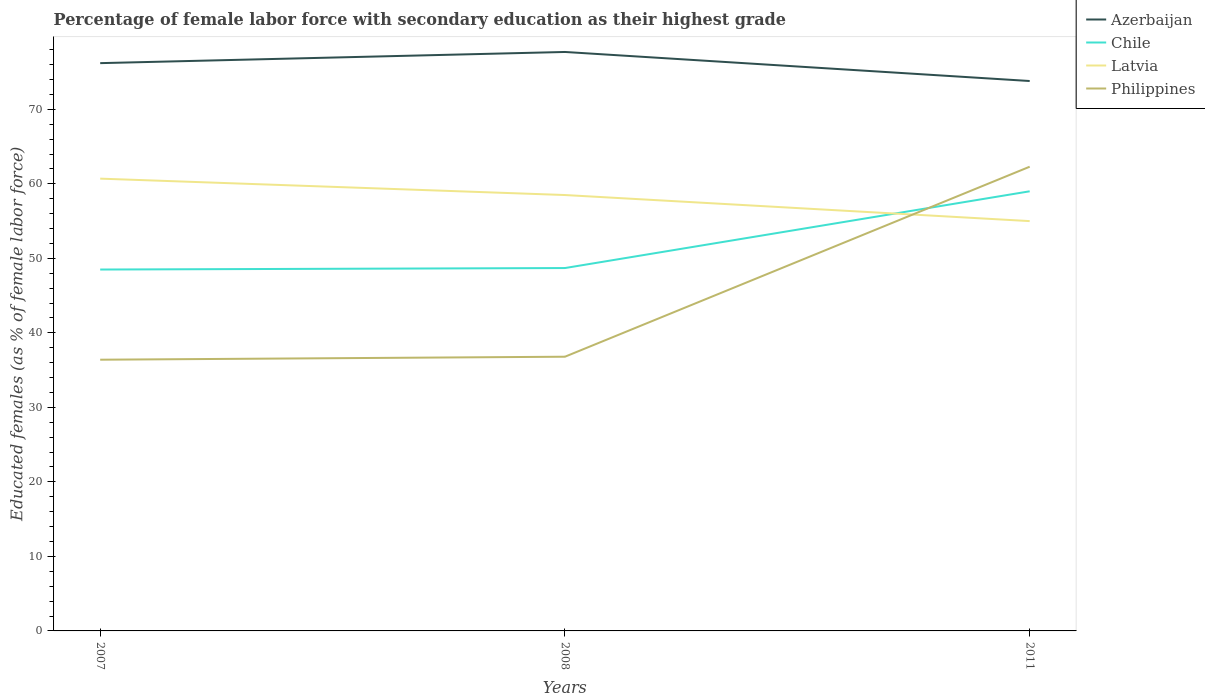How many different coloured lines are there?
Offer a very short reply. 4. Does the line corresponding to Latvia intersect with the line corresponding to Azerbaijan?
Make the answer very short. No. Is the number of lines equal to the number of legend labels?
Keep it short and to the point. Yes. Across all years, what is the maximum percentage of female labor force with secondary education in Azerbaijan?
Your answer should be compact. 73.8. In which year was the percentage of female labor force with secondary education in Philippines maximum?
Keep it short and to the point. 2007. What is the total percentage of female labor force with secondary education in Azerbaijan in the graph?
Your answer should be very brief. -1.5. What is the difference between the highest and the second highest percentage of female labor force with secondary education in Azerbaijan?
Offer a terse response. 3.9. What is the difference between the highest and the lowest percentage of female labor force with secondary education in Chile?
Ensure brevity in your answer.  1. Is the percentage of female labor force with secondary education in Chile strictly greater than the percentage of female labor force with secondary education in Azerbaijan over the years?
Your answer should be compact. Yes. How many years are there in the graph?
Provide a short and direct response. 3. Does the graph contain grids?
Your answer should be very brief. No. Where does the legend appear in the graph?
Offer a terse response. Top right. What is the title of the graph?
Ensure brevity in your answer.  Percentage of female labor force with secondary education as their highest grade. Does "Jamaica" appear as one of the legend labels in the graph?
Your answer should be compact. No. What is the label or title of the X-axis?
Ensure brevity in your answer.  Years. What is the label or title of the Y-axis?
Your answer should be compact. Educated females (as % of female labor force). What is the Educated females (as % of female labor force) in Azerbaijan in 2007?
Provide a succinct answer. 76.2. What is the Educated females (as % of female labor force) in Chile in 2007?
Your answer should be very brief. 48.5. What is the Educated females (as % of female labor force) in Latvia in 2007?
Your answer should be very brief. 60.7. What is the Educated females (as % of female labor force) of Philippines in 2007?
Your answer should be very brief. 36.4. What is the Educated females (as % of female labor force) of Azerbaijan in 2008?
Offer a terse response. 77.7. What is the Educated females (as % of female labor force) of Chile in 2008?
Offer a very short reply. 48.7. What is the Educated females (as % of female labor force) in Latvia in 2008?
Keep it short and to the point. 58.5. What is the Educated females (as % of female labor force) of Philippines in 2008?
Offer a terse response. 36.8. What is the Educated females (as % of female labor force) in Azerbaijan in 2011?
Give a very brief answer. 73.8. What is the Educated females (as % of female labor force) in Chile in 2011?
Keep it short and to the point. 59. What is the Educated females (as % of female labor force) in Latvia in 2011?
Your answer should be very brief. 55. What is the Educated females (as % of female labor force) in Philippines in 2011?
Give a very brief answer. 62.3. Across all years, what is the maximum Educated females (as % of female labor force) of Azerbaijan?
Provide a short and direct response. 77.7. Across all years, what is the maximum Educated females (as % of female labor force) in Chile?
Your answer should be very brief. 59. Across all years, what is the maximum Educated females (as % of female labor force) of Latvia?
Keep it short and to the point. 60.7. Across all years, what is the maximum Educated females (as % of female labor force) of Philippines?
Your answer should be very brief. 62.3. Across all years, what is the minimum Educated females (as % of female labor force) in Azerbaijan?
Your answer should be very brief. 73.8. Across all years, what is the minimum Educated females (as % of female labor force) in Chile?
Keep it short and to the point. 48.5. Across all years, what is the minimum Educated females (as % of female labor force) of Latvia?
Make the answer very short. 55. Across all years, what is the minimum Educated females (as % of female labor force) of Philippines?
Ensure brevity in your answer.  36.4. What is the total Educated females (as % of female labor force) of Azerbaijan in the graph?
Provide a succinct answer. 227.7. What is the total Educated females (as % of female labor force) in Chile in the graph?
Give a very brief answer. 156.2. What is the total Educated females (as % of female labor force) of Latvia in the graph?
Make the answer very short. 174.2. What is the total Educated females (as % of female labor force) of Philippines in the graph?
Your answer should be compact. 135.5. What is the difference between the Educated females (as % of female labor force) of Azerbaijan in 2007 and that in 2008?
Provide a succinct answer. -1.5. What is the difference between the Educated females (as % of female labor force) in Philippines in 2007 and that in 2008?
Your answer should be very brief. -0.4. What is the difference between the Educated females (as % of female labor force) of Philippines in 2007 and that in 2011?
Offer a very short reply. -25.9. What is the difference between the Educated females (as % of female labor force) of Azerbaijan in 2008 and that in 2011?
Provide a short and direct response. 3.9. What is the difference between the Educated females (as % of female labor force) of Philippines in 2008 and that in 2011?
Offer a terse response. -25.5. What is the difference between the Educated females (as % of female labor force) of Azerbaijan in 2007 and the Educated females (as % of female labor force) of Chile in 2008?
Keep it short and to the point. 27.5. What is the difference between the Educated females (as % of female labor force) of Azerbaijan in 2007 and the Educated females (as % of female labor force) of Philippines in 2008?
Make the answer very short. 39.4. What is the difference between the Educated females (as % of female labor force) of Chile in 2007 and the Educated females (as % of female labor force) of Latvia in 2008?
Provide a short and direct response. -10. What is the difference between the Educated females (as % of female labor force) in Latvia in 2007 and the Educated females (as % of female labor force) in Philippines in 2008?
Make the answer very short. 23.9. What is the difference between the Educated females (as % of female labor force) in Azerbaijan in 2007 and the Educated females (as % of female labor force) in Chile in 2011?
Provide a succinct answer. 17.2. What is the difference between the Educated females (as % of female labor force) of Azerbaijan in 2007 and the Educated females (as % of female labor force) of Latvia in 2011?
Your response must be concise. 21.2. What is the difference between the Educated females (as % of female labor force) of Azerbaijan in 2007 and the Educated females (as % of female labor force) of Philippines in 2011?
Your answer should be very brief. 13.9. What is the difference between the Educated females (as % of female labor force) in Chile in 2007 and the Educated females (as % of female labor force) in Latvia in 2011?
Your answer should be compact. -6.5. What is the difference between the Educated females (as % of female labor force) of Chile in 2007 and the Educated females (as % of female labor force) of Philippines in 2011?
Your answer should be compact. -13.8. What is the difference between the Educated females (as % of female labor force) of Azerbaijan in 2008 and the Educated females (as % of female labor force) of Latvia in 2011?
Your answer should be compact. 22.7. What is the difference between the Educated females (as % of female labor force) of Chile in 2008 and the Educated females (as % of female labor force) of Latvia in 2011?
Make the answer very short. -6.3. What is the difference between the Educated females (as % of female labor force) of Latvia in 2008 and the Educated females (as % of female labor force) of Philippines in 2011?
Make the answer very short. -3.8. What is the average Educated females (as % of female labor force) in Azerbaijan per year?
Provide a short and direct response. 75.9. What is the average Educated females (as % of female labor force) of Chile per year?
Your answer should be very brief. 52.07. What is the average Educated females (as % of female labor force) of Latvia per year?
Your response must be concise. 58.07. What is the average Educated females (as % of female labor force) of Philippines per year?
Ensure brevity in your answer.  45.17. In the year 2007, what is the difference between the Educated females (as % of female labor force) in Azerbaijan and Educated females (as % of female labor force) in Chile?
Your answer should be compact. 27.7. In the year 2007, what is the difference between the Educated females (as % of female labor force) of Azerbaijan and Educated females (as % of female labor force) of Latvia?
Your answer should be very brief. 15.5. In the year 2007, what is the difference between the Educated females (as % of female labor force) in Azerbaijan and Educated females (as % of female labor force) in Philippines?
Give a very brief answer. 39.8. In the year 2007, what is the difference between the Educated females (as % of female labor force) of Chile and Educated females (as % of female labor force) of Latvia?
Your answer should be very brief. -12.2. In the year 2007, what is the difference between the Educated females (as % of female labor force) in Chile and Educated females (as % of female labor force) in Philippines?
Your answer should be compact. 12.1. In the year 2007, what is the difference between the Educated females (as % of female labor force) of Latvia and Educated females (as % of female labor force) of Philippines?
Your response must be concise. 24.3. In the year 2008, what is the difference between the Educated females (as % of female labor force) in Azerbaijan and Educated females (as % of female labor force) in Chile?
Provide a succinct answer. 29. In the year 2008, what is the difference between the Educated females (as % of female labor force) in Azerbaijan and Educated females (as % of female labor force) in Latvia?
Give a very brief answer. 19.2. In the year 2008, what is the difference between the Educated females (as % of female labor force) in Azerbaijan and Educated females (as % of female labor force) in Philippines?
Provide a succinct answer. 40.9. In the year 2008, what is the difference between the Educated females (as % of female labor force) of Chile and Educated females (as % of female labor force) of Latvia?
Your answer should be compact. -9.8. In the year 2008, what is the difference between the Educated females (as % of female labor force) of Latvia and Educated females (as % of female labor force) of Philippines?
Provide a succinct answer. 21.7. In the year 2011, what is the difference between the Educated females (as % of female labor force) of Azerbaijan and Educated females (as % of female labor force) of Chile?
Your response must be concise. 14.8. In the year 2011, what is the difference between the Educated females (as % of female labor force) of Azerbaijan and Educated females (as % of female labor force) of Latvia?
Ensure brevity in your answer.  18.8. What is the ratio of the Educated females (as % of female labor force) in Azerbaijan in 2007 to that in 2008?
Your answer should be compact. 0.98. What is the ratio of the Educated females (as % of female labor force) in Chile in 2007 to that in 2008?
Give a very brief answer. 1. What is the ratio of the Educated females (as % of female labor force) in Latvia in 2007 to that in 2008?
Make the answer very short. 1.04. What is the ratio of the Educated females (as % of female labor force) in Philippines in 2007 to that in 2008?
Your answer should be compact. 0.99. What is the ratio of the Educated females (as % of female labor force) in Azerbaijan in 2007 to that in 2011?
Provide a short and direct response. 1.03. What is the ratio of the Educated females (as % of female labor force) in Chile in 2007 to that in 2011?
Ensure brevity in your answer.  0.82. What is the ratio of the Educated females (as % of female labor force) of Latvia in 2007 to that in 2011?
Provide a succinct answer. 1.1. What is the ratio of the Educated females (as % of female labor force) of Philippines in 2007 to that in 2011?
Your answer should be very brief. 0.58. What is the ratio of the Educated females (as % of female labor force) of Azerbaijan in 2008 to that in 2011?
Your answer should be very brief. 1.05. What is the ratio of the Educated females (as % of female labor force) in Chile in 2008 to that in 2011?
Your response must be concise. 0.83. What is the ratio of the Educated females (as % of female labor force) in Latvia in 2008 to that in 2011?
Your answer should be very brief. 1.06. What is the ratio of the Educated females (as % of female labor force) in Philippines in 2008 to that in 2011?
Ensure brevity in your answer.  0.59. What is the difference between the highest and the second highest Educated females (as % of female labor force) of Azerbaijan?
Make the answer very short. 1.5. What is the difference between the highest and the second highest Educated females (as % of female labor force) of Latvia?
Ensure brevity in your answer.  2.2. What is the difference between the highest and the second highest Educated females (as % of female labor force) of Philippines?
Your answer should be compact. 25.5. What is the difference between the highest and the lowest Educated females (as % of female labor force) in Chile?
Ensure brevity in your answer.  10.5. What is the difference between the highest and the lowest Educated females (as % of female labor force) of Philippines?
Your answer should be compact. 25.9. 